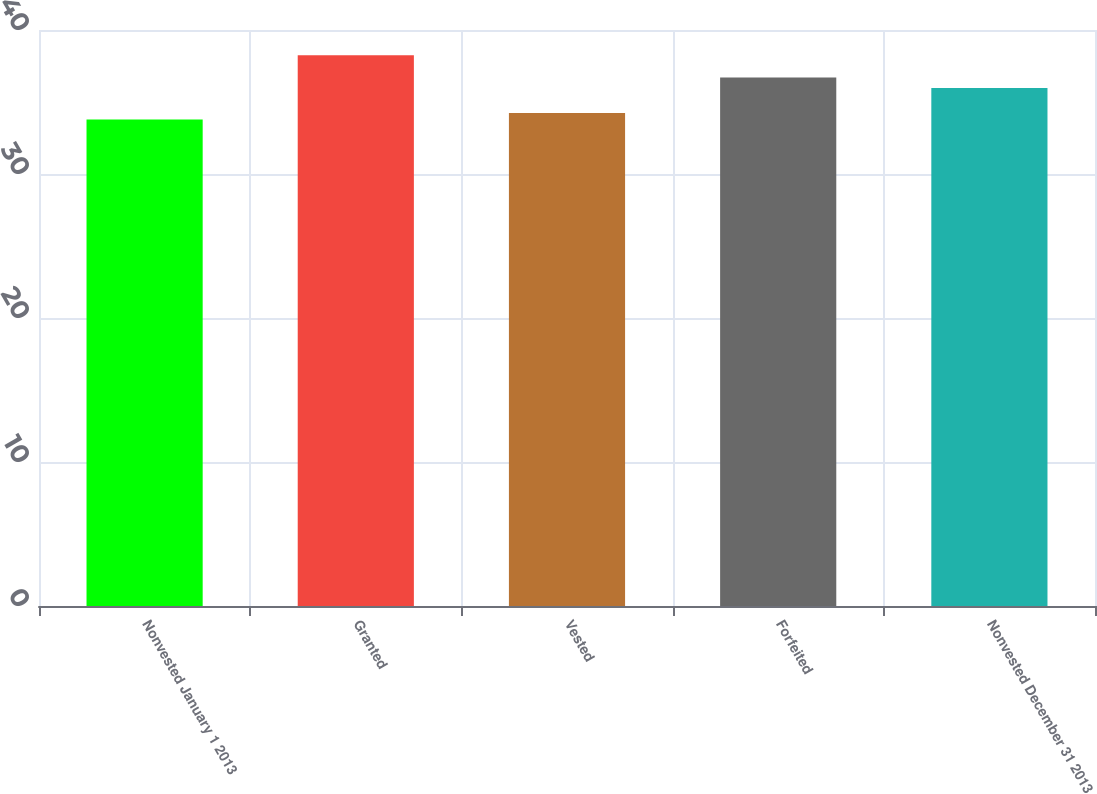<chart> <loc_0><loc_0><loc_500><loc_500><bar_chart><fcel>Nonvested January 1 2013<fcel>Granted<fcel>Vested<fcel>Forfeited<fcel>Nonvested December 31 2013<nl><fcel>33.78<fcel>38.25<fcel>34.23<fcel>36.71<fcel>35.98<nl></chart> 